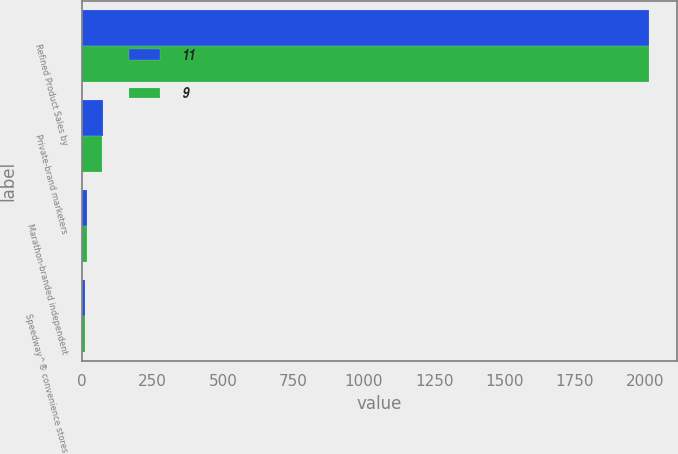<chart> <loc_0><loc_0><loc_500><loc_500><stacked_bar_chart><ecel><fcel>Refined Product Sales by<fcel>Private-brand marketers<fcel>Marathon-branded independent<fcel>Speedway^® convenience stores<nl><fcel>11<fcel>2013<fcel>75<fcel>16<fcel>9<nl><fcel>9<fcel>2012<fcel>72<fcel>17<fcel>11<nl></chart> 